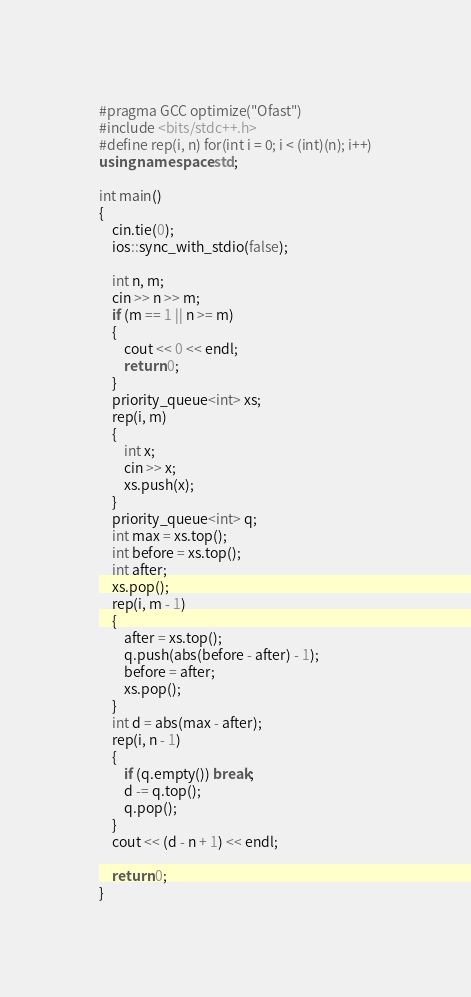<code> <loc_0><loc_0><loc_500><loc_500><_C++_>#pragma GCC optimize("Ofast")
#include <bits/stdc++.h>
#define rep(i, n) for(int i = 0; i < (int)(n); i++)
using namespace std;

int main()
{
    cin.tie(0);
    ios::sync_with_stdio(false);

    int n, m;
    cin >> n >> m;
    if (m == 1 || n >= m)
    {
        cout << 0 << endl;
        return 0;
    }
    priority_queue<int> xs;
    rep(i, m)
    {
        int x;
        cin >> x;
        xs.push(x);
    }
    priority_queue<int> q;
    int max = xs.top();
    int before = xs.top();
    int after;
    xs.pop();
    rep(i, m - 1)
    {
        after = xs.top();
        q.push(abs(before - after) - 1);
        before = after;
        xs.pop();
    }
    int d = abs(max - after);
    rep(i, n - 1)
    {
        if (q.empty()) break;
        d -= q.top();
        q.pop();
    }
    cout << (d - n + 1) << endl;

    return 0;
}</code> 